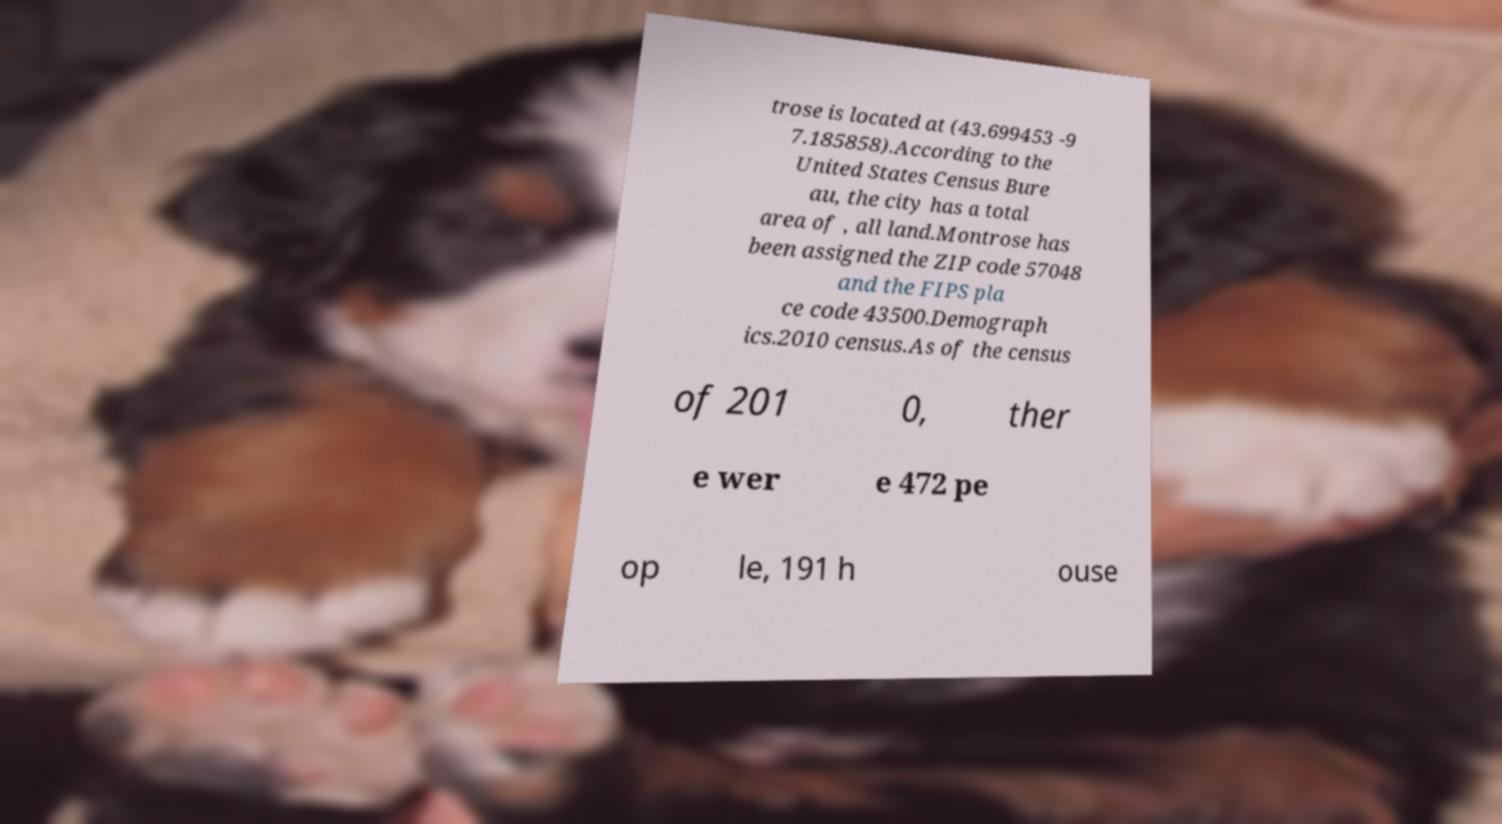Could you assist in decoding the text presented in this image and type it out clearly? trose is located at (43.699453 -9 7.185858).According to the United States Census Bure au, the city has a total area of , all land.Montrose has been assigned the ZIP code 57048 and the FIPS pla ce code 43500.Demograph ics.2010 census.As of the census of 201 0, ther e wer e 472 pe op le, 191 h ouse 